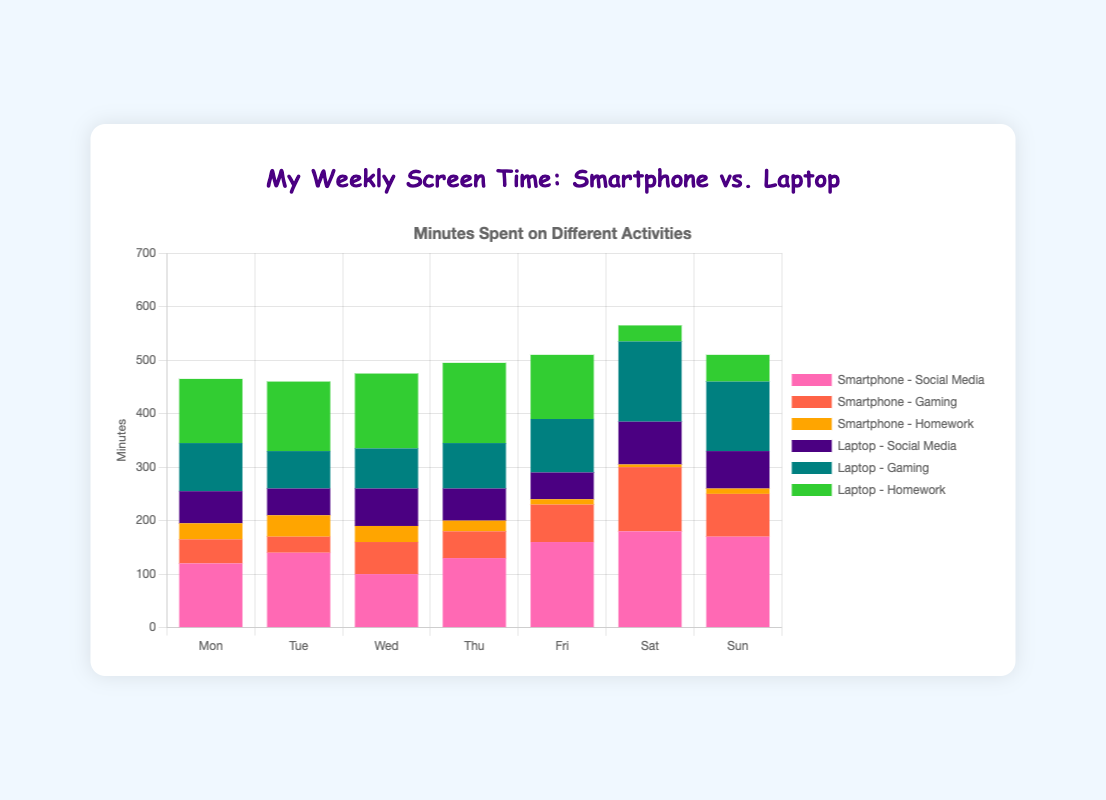What day has the highest total screen time for social media on the smartphone? Look at the height of the pink bars representing smartphone social media usage on different days. The tallest pink bar is on Saturday, which means Saturday has the highest total screen time for social media on the smartphone.
Answer: Saturday Which device is used more for social media on Wednesday, and by how much? Compare the height of the pink bars for smartphones and laptops on Wednesday. The smartphone bar is 100 minutes, and the laptop bar is 70 minutes. The smartphone is used more by a difference of 30 minutes.
Answer: Smartphone, by 30 minutes Which day has the least amount of gaming on the laptop? Look for the shortest turquoise bar representing laptop gaming across all days. The shortest turquoise bar is on Tuesday, indicating Tuesday has the least amount of gaming on the laptop.
Answer: Tuesday What is the total screen time distribution for homework on Friday? Add the height of the orange bar (smartphone homework) and the lime green bar (laptop homework) on Friday. The smartphone homework time is 10 minutes, and the laptop homework time is 120 minutes, giving a total of 10 + 120 = 130 minutes.
Answer: 130 minutes Compare the total screen time for gaming on smartphones and laptops on Thursday. Which is higher and by how much? Check the red bar (smartphone gaming) and the turquoise bar (laptop gaming) on Thursday. Smartphone gaming is 50 minutes, and laptop gaming is 85 minutes. Laptop gaming is higher by 85 - 50 = 35 minutes.
Answer: Laptop by 35 minutes On which day do teens spend the most time on their laptop doing homework? Find the tallest lime green bar for laptop homework over the week. The tallest lime green bar is on Thursday, indicating Thursday is the day with the most laptop homework time.
Answer: Thursday What is the average daily screen time for social media on the laptop? Sum the laptop social media times for each day (60 + 50 + 70 + 60 + 50 + 80 + 70 = 440 minutes) and divide by the number of days (7). The average is 440 / 7 = 62.86 minutes.
Answer: 62.86 minutes What is the total screen time for gaming on Saturday, combining smartphone and laptop usage? Add the red bar (smartphone gaming) and the turquoise bar (laptop gaming) on Saturday. Smartphone gaming is 120 minutes, and laptop gaming is 150 minutes. The total is 120 + 150 = 270 minutes.
Answer: 270 minutes How does Friday's total screen time for social media compare between smartphone and laptop? Look at the pink bars for smartphones and laptops on Friday. Smartphone social media is 160 minutes, and laptop social media is 50 minutes. Smartphone usage is significantly higher by 160 - 50 = 110 minutes.
Answer: Smartphone by 110 minutes On which day is the screen time for social media the same for both devices? Look for any day where the pink bars (smartphone) and the purple bars (laptop) are of equal height. There is no day where these bars are of equal height, so the social media screen time is never the same for both devices on any given day.
Answer: None 